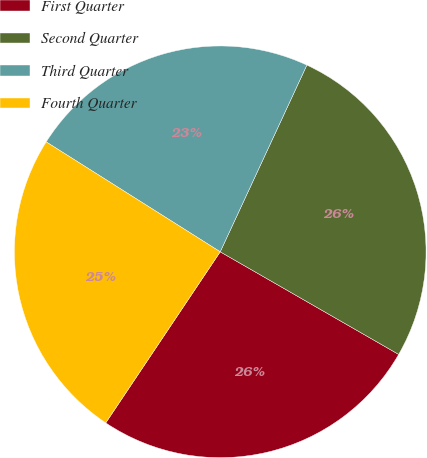Convert chart to OTSL. <chart><loc_0><loc_0><loc_500><loc_500><pie_chart><fcel>First Quarter<fcel>Second Quarter<fcel>Third Quarter<fcel>Fourth Quarter<nl><fcel>26.08%<fcel>26.39%<fcel>22.95%<fcel>24.58%<nl></chart> 